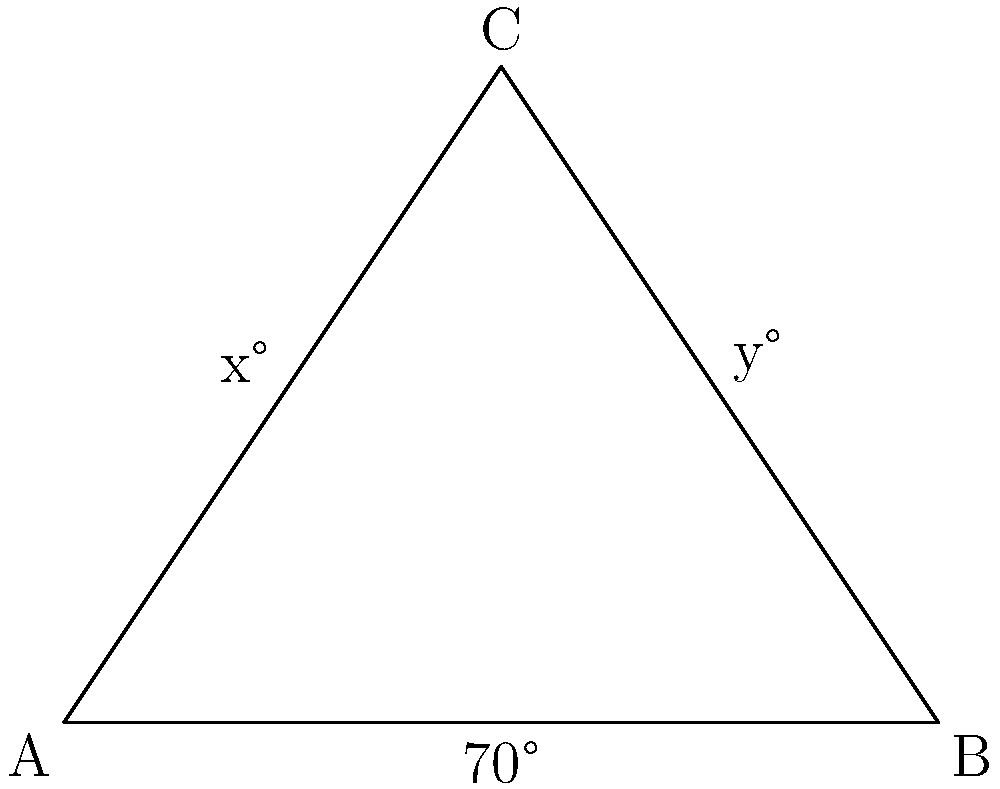In a network of intersecting data transmission lines, three main nodes form a triangle ABC. The angle at B is 70°, and the bisector of angle C creates two angles x° and y° with the sides of the triangle. If x° = y°, what is the value of x? To solve this problem, let's follow these steps:

1) In triangle ABC, we know that angle B is 70°.

2) The sum of angles in a triangle is always 180°. So:
   $$\angle A + \angle B + \angle C = 180°$$
   $$\angle A + 70° + \angle C = 180°$$

3) The bisector of angle C divides it into two equal parts, x° and y°. Since x° = y°, we can say that:
   $$\angle C = x° + y° = 2x°$$

4) Substituting this into our equation from step 2:
   $$\angle A + 70° + 2x° = 180°$$

5) We also know that angle A plus angle C must equal 110° (since B is 70° and the sum is 180°):
   $$\angle A + 2x° = 110°$$

6) Substituting this into our equation from step 4:
   $$110° + 70° = 180°$$

   This confirms our calculations are correct.

7) Now, solving for x in the equation from step 5:
   $$\angle A + 2x° = 110°$$
   $$2x° = 110° - \angle A$$
   $$2x° = 110° - (110° - 2x°)$$ (substituting $\angle A = 110° - 2x°$)
   $$2x° = 2x°$$

8) This means our assumption that x° = y° is correct, and:
   $$x° = 110° ÷ 4 = 27.5°$$

Therefore, the value of x is 27.5°.
Answer: 27.5° 